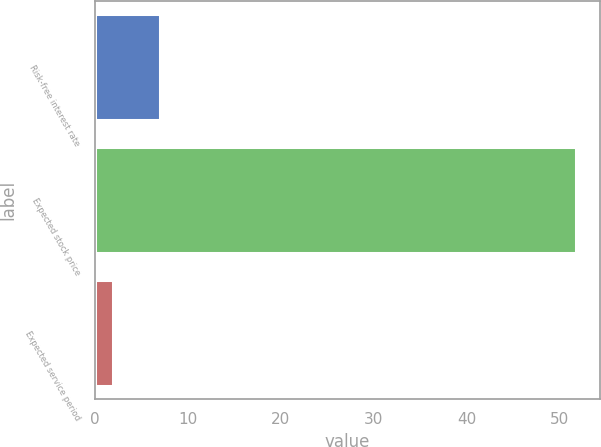<chart> <loc_0><loc_0><loc_500><loc_500><bar_chart><fcel>Risk-free interest rate<fcel>Expected stock price<fcel>Expected service period<nl><fcel>6.98<fcel>51.8<fcel>2<nl></chart> 